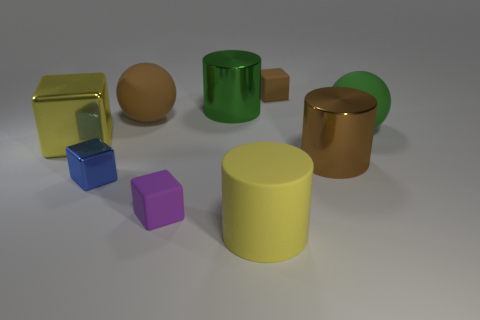Add 1 purple things. How many objects exist? 10 Subtract all spheres. How many objects are left? 7 Add 3 big yellow blocks. How many big yellow blocks are left? 4 Add 7 small brown cubes. How many small brown cubes exist? 8 Subtract 0 yellow spheres. How many objects are left? 9 Subtract all purple matte cubes. Subtract all metallic cubes. How many objects are left? 6 